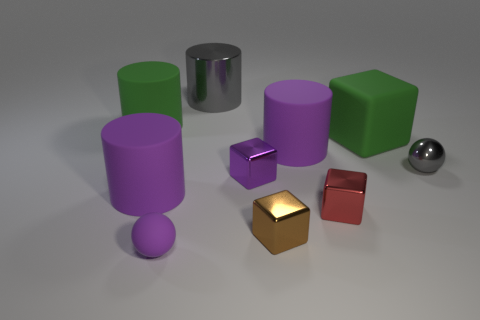Do the large purple thing on the left side of the purple shiny object and the gray shiny thing on the left side of the large block have the same shape?
Offer a very short reply. Yes. What color is the large cylinder that is made of the same material as the small purple cube?
Give a very brief answer. Gray. Are there fewer big gray things to the left of the green cylinder than big purple matte spheres?
Offer a terse response. No. There is a gray thing that is in front of the metal thing that is behind the large green thing that is to the right of the gray cylinder; what size is it?
Your response must be concise. Small. Are the tiny sphere left of the tiny brown shiny thing and the purple cube made of the same material?
Ensure brevity in your answer.  No. There is a small block that is the same color as the small matte object; what material is it?
Provide a succinct answer. Metal. Is there anything else that has the same shape as the small purple shiny object?
Keep it short and to the point. Yes. What number of things are small purple metal things or small purple matte objects?
Your answer should be very brief. 2. There is a red object that is the same shape as the purple metal object; what is its size?
Provide a succinct answer. Small. Is there any other thing that is the same size as the purple rubber ball?
Your response must be concise. Yes. 